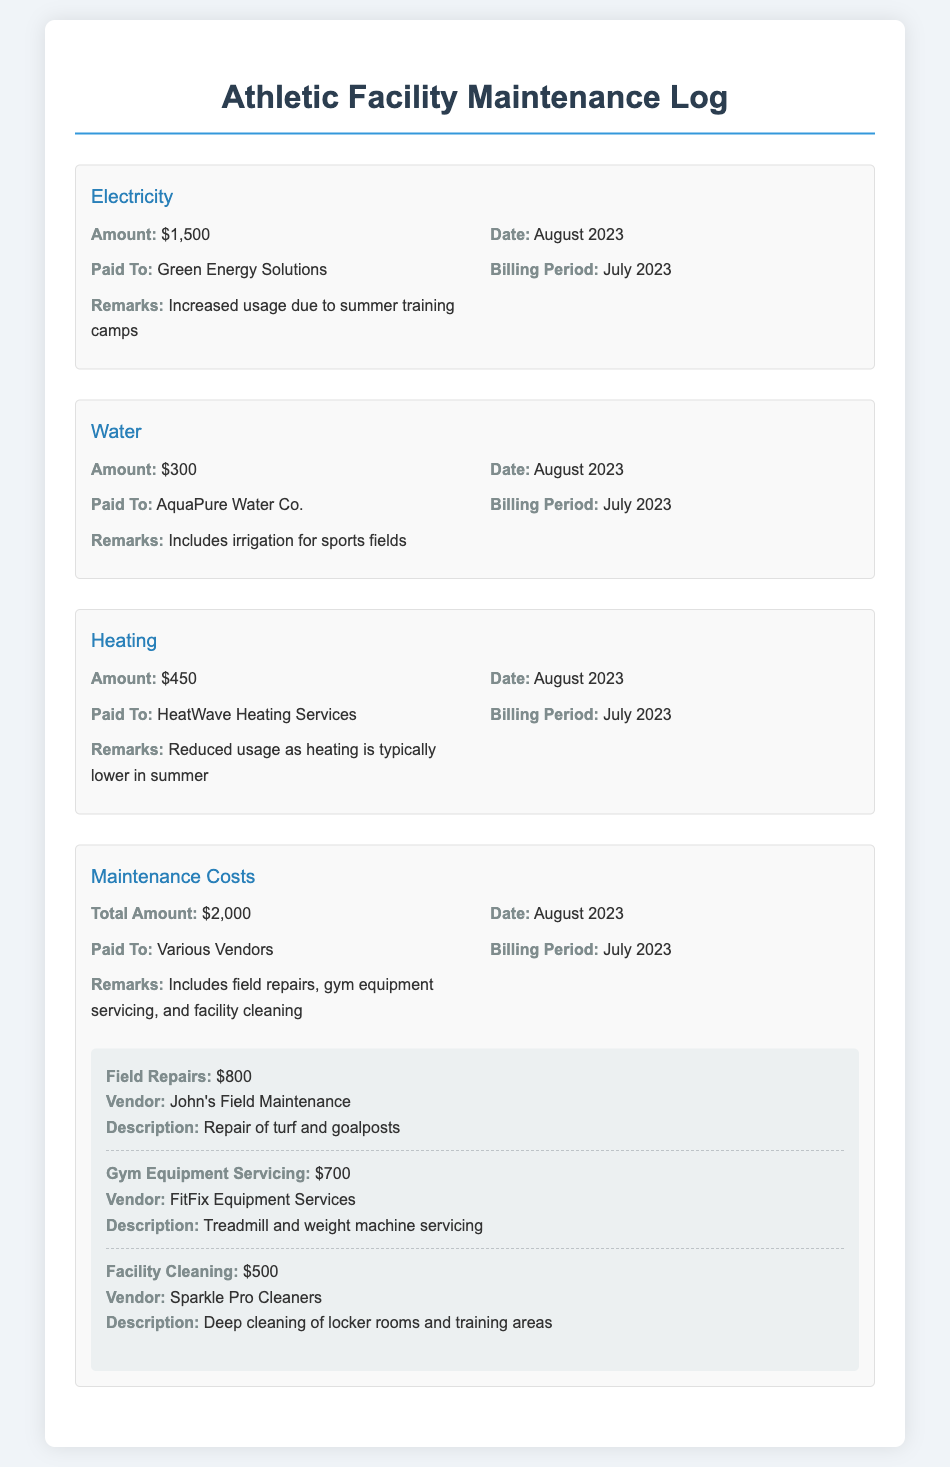What is the amount for electricity? The document states that the amount for electricity is $1500.
Answer: $1500 Who was the electricity bill paid to? The electricity bill was paid to Green Energy Solutions.
Answer: Green Energy Solutions What was the total amount for maintenance costs? The total amount for maintenance costs listed in the document is $2000.
Answer: $2000 What does the water expense include? The water expense includes irrigation for sports fields.
Answer: irrigation for sports fields Did the heating cost increase or decrease from summer usage? The heating cost decrease was mentioned as heating usage is typically lower in summer.
Answer: decrease How much was spent on gym equipment servicing? The amount spent on gym equipment servicing is $700.
Answer: $700 What was the reason for increased electricity usage? Increased usage was due to summer training camps.
Answer: summer training camps What is the payment date for all expenses in the document? The payment date for all expenses listed in the document is August 2023.
Answer: August 2023 What is one of the vendors for facility cleaning? One of the vendors for facility cleaning is Sparkle Pro Cleaners.
Answer: Sparkle Pro Cleaners 